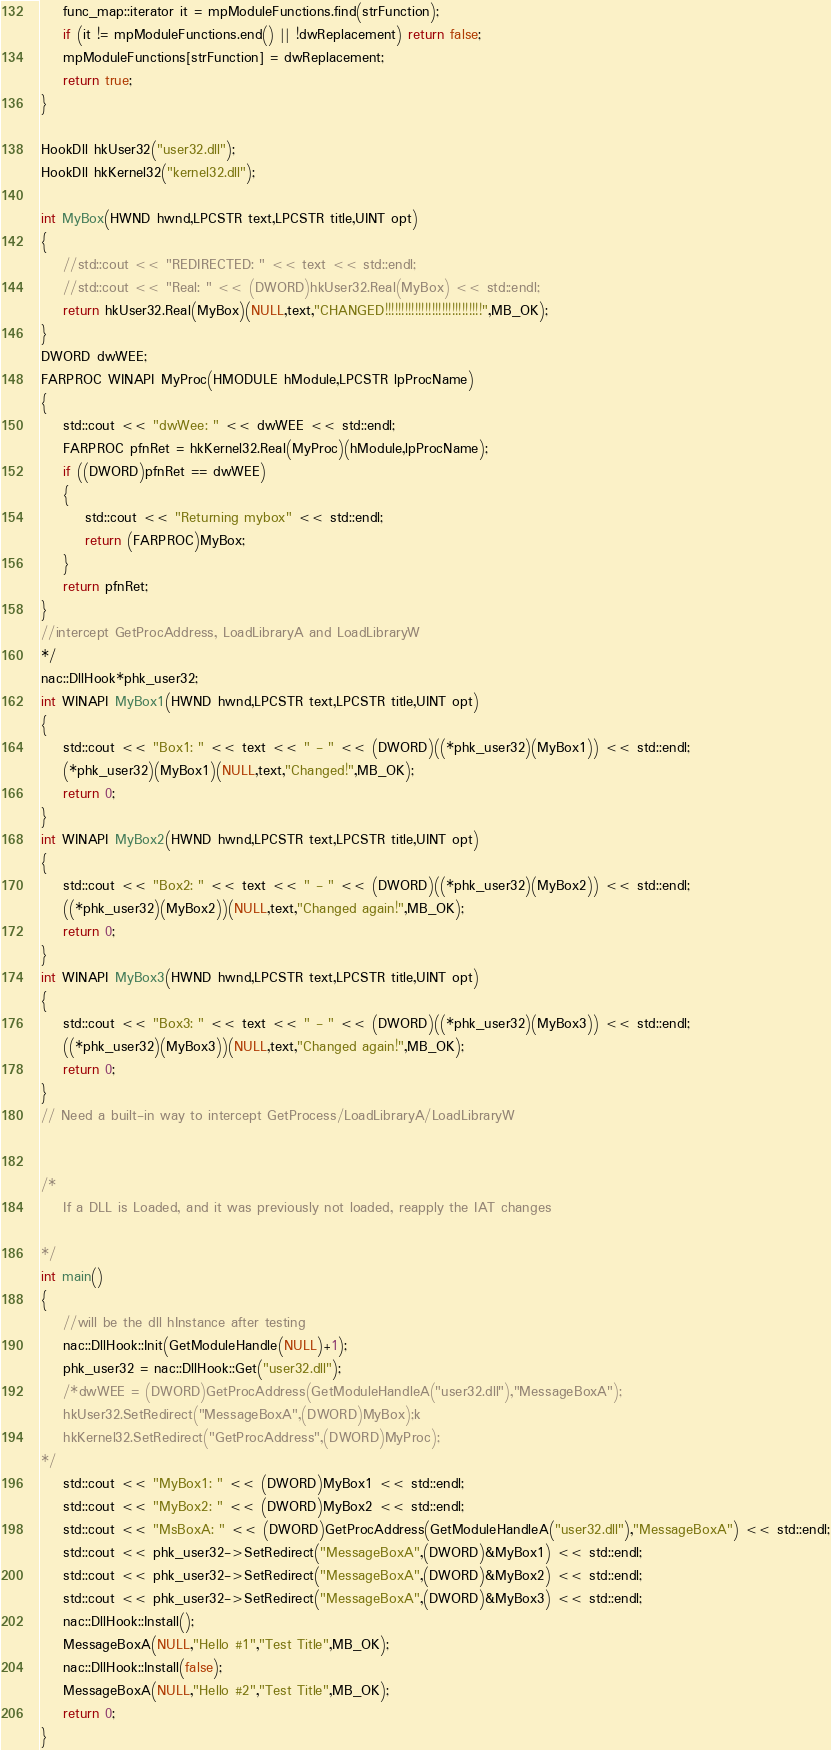<code> <loc_0><loc_0><loc_500><loc_500><_C++_>	func_map::iterator it = mpModuleFunctions.find(strFunction);
	if (it != mpModuleFunctions.end() || !dwReplacement) return false;
	mpModuleFunctions[strFunction] = dwReplacement;
	return true;
}

HookDll hkUser32("user32.dll");
HookDll hkKernel32("kernel32.dll");

int MyBox(HWND hwnd,LPCSTR text,LPCSTR title,UINT opt)
{
	//std::cout << "REDIRECTED: " << text << std::endl;
	//std::cout << "Real: " << (DWORD)hkUser32.Real(MyBox) << std::endl;
	return hkUser32.Real(MyBox)(NULL,text,"CHANGED!!!!!!!!!!!!!!!!!!!!!!!!!!!!!",MB_OK);
}
DWORD dwWEE;
FARPROC WINAPI MyProc(HMODULE hModule,LPCSTR lpProcName)
{
	std::cout << "dwWee: " << dwWEE << std::endl;
	FARPROC pfnRet = hkKernel32.Real(MyProc)(hModule,lpProcName);
	if ((DWORD)pfnRet == dwWEE)
	{
		std::cout << "Returning mybox" << std::endl;
		return (FARPROC)MyBox;
	}
	return pfnRet;
}
//intercept GetProcAddress, LoadLibraryA and LoadLibraryW
*/
nac::DllHook*phk_user32;
int WINAPI MyBox1(HWND hwnd,LPCSTR text,LPCSTR title,UINT opt)
{
	std::cout << "Box1: " << text << " - " << (DWORD)((*phk_user32)(MyBox1)) << std::endl;
	(*phk_user32)(MyBox1)(NULL,text,"Changed!",MB_OK);
	return 0;
}
int WINAPI MyBox2(HWND hwnd,LPCSTR text,LPCSTR title,UINT opt)
{
	std::cout << "Box2: " << text << " - " << (DWORD)((*phk_user32)(MyBox2)) << std::endl;
	((*phk_user32)(MyBox2))(NULL,text,"Changed again!",MB_OK);
	return 0;
}
int WINAPI MyBox3(HWND hwnd,LPCSTR text,LPCSTR title,UINT opt)
{
	std::cout << "Box3: " << text << " - " << (DWORD)((*phk_user32)(MyBox3)) << std::endl;
	((*phk_user32)(MyBox3))(NULL,text,"Changed again!",MB_OK);
	return 0;
}
// Need a built-in way to intercept GetProcess/LoadLibraryA/LoadLibraryW


/*
	If a DLL is Loaded, and it was previously not loaded, reapply the IAT changes

*/
int main()
{
	//will be the dll hInstance after testing
	nac::DllHook::Init(GetModuleHandle(NULL)+1);
	phk_user32 = nac::DllHook::Get("user32.dll");
	/*dwWEE = (DWORD)GetProcAddress(GetModuleHandleA("user32.dll"),"MessageBoxA");
	hkUser32.SetRedirect("MessageBoxA",(DWORD)MyBox);k
	hkKernel32.SetRedirect("GetProcAddress",(DWORD)MyProc);
*/
	std::cout << "MyBox1: " << (DWORD)MyBox1 << std::endl;
	std::cout << "MyBox2: " << (DWORD)MyBox2 << std::endl;
	std::cout << "MsBoxA: " << (DWORD)GetProcAddress(GetModuleHandleA("user32.dll"),"MessageBoxA") << std::endl;
	std::cout << phk_user32->SetRedirect("MessageBoxA",(DWORD)&MyBox1) << std::endl;
	std::cout << phk_user32->SetRedirect("MessageBoxA",(DWORD)&MyBox2) << std::endl;
	std::cout << phk_user32->SetRedirect("MessageBoxA",(DWORD)&MyBox3) << std::endl;
	nac::DllHook::Install();
	MessageBoxA(NULL,"Hello #1","Test Title",MB_OK);
	nac::DllHook::Install(false);
	MessageBoxA(NULL,"Hello #2","Test Title",MB_OK);
    return 0;
}
</code> 